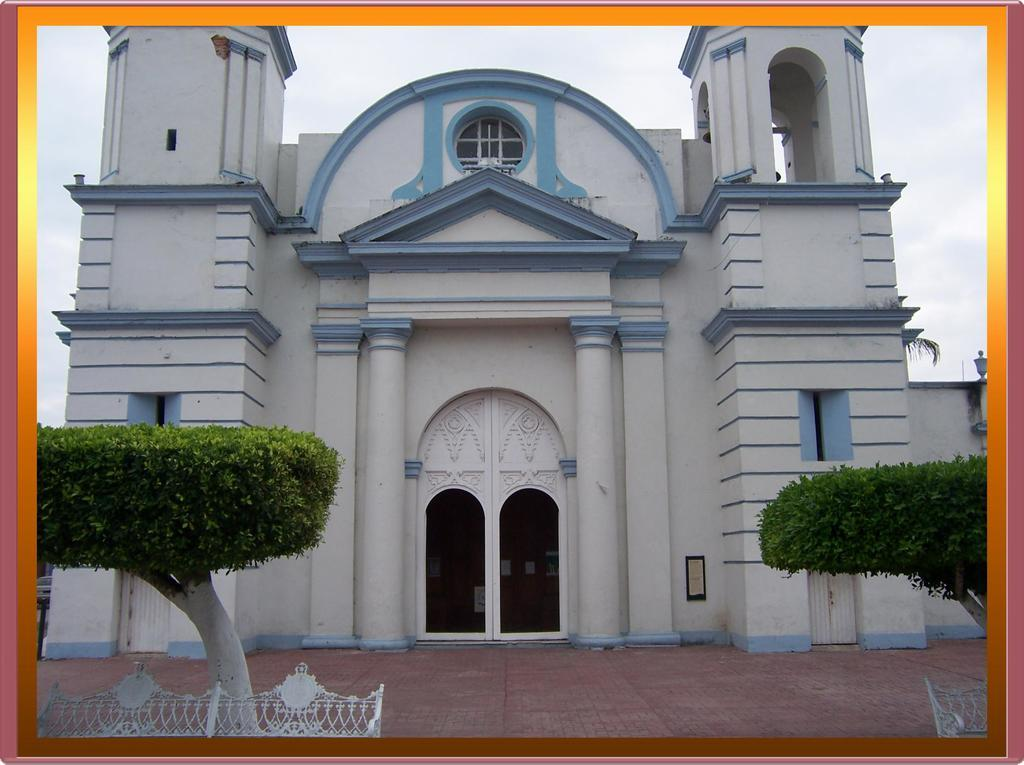What type of structure is present in the image? There is a building in the image. What other natural elements can be seen in the image? There are trees in the image. Is there any barrier or enclosure visible in the image? Yes, there is a fence in the image. Are there any openings or entrances in the building? Yes, there are doors in the image. What can be seen in the background of the image? The sky is visible in the background of the image. What type of skirt is the boy wearing in the image? There is no boy or skirt present in the image. What sound does the thunder make in the image? There is no thunder present in the image. 